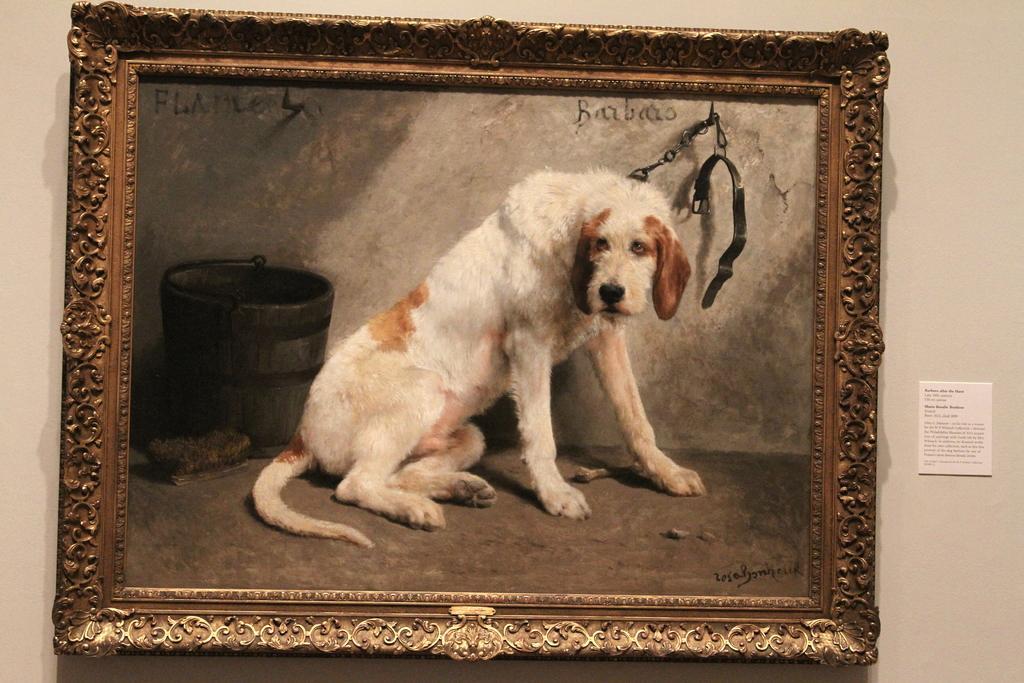In one or two sentences, can you explain what this image depicts? In the center of the image we can see a photo frame of a dog placed on the wall. 